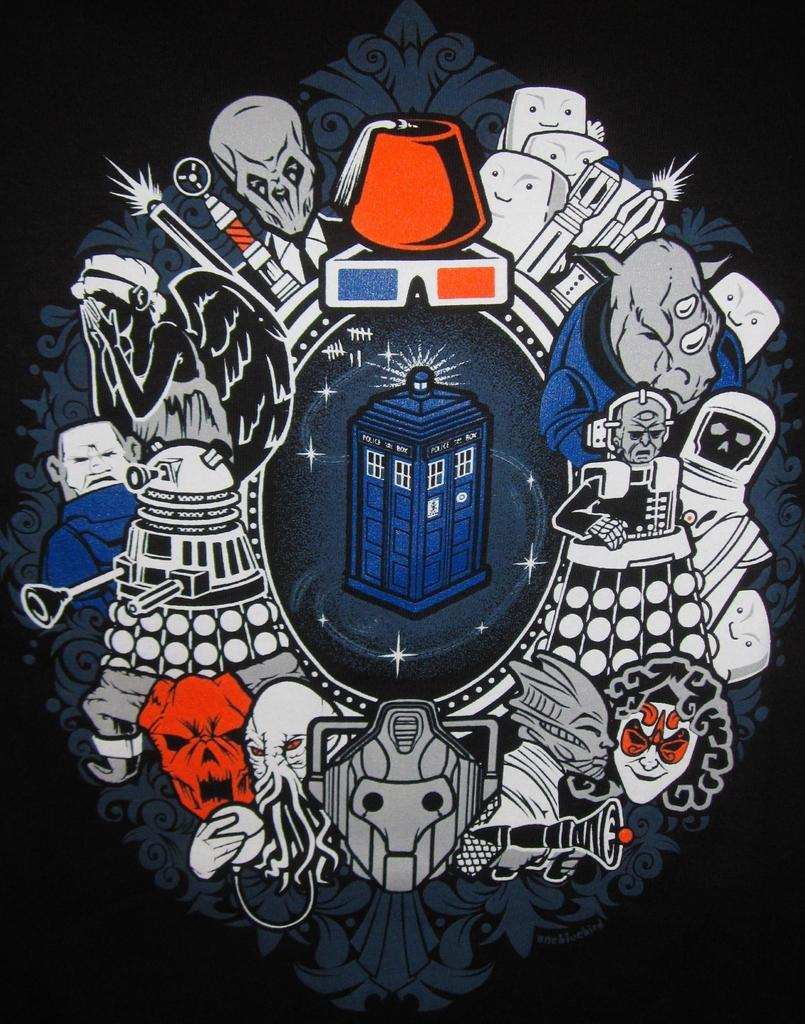What is present in the image that features a visual representation? There is a poster in the image. What type of images are depicted on the poster? The poster consists of cartoon images. What type of prose can be seen on the poster in the image? There is no prose present on the poster in the image, as it consists of cartoon images. How many cats are visible on the poster in the image? There is no information about cats on the poster in the image, as it consists of cartoon images. 